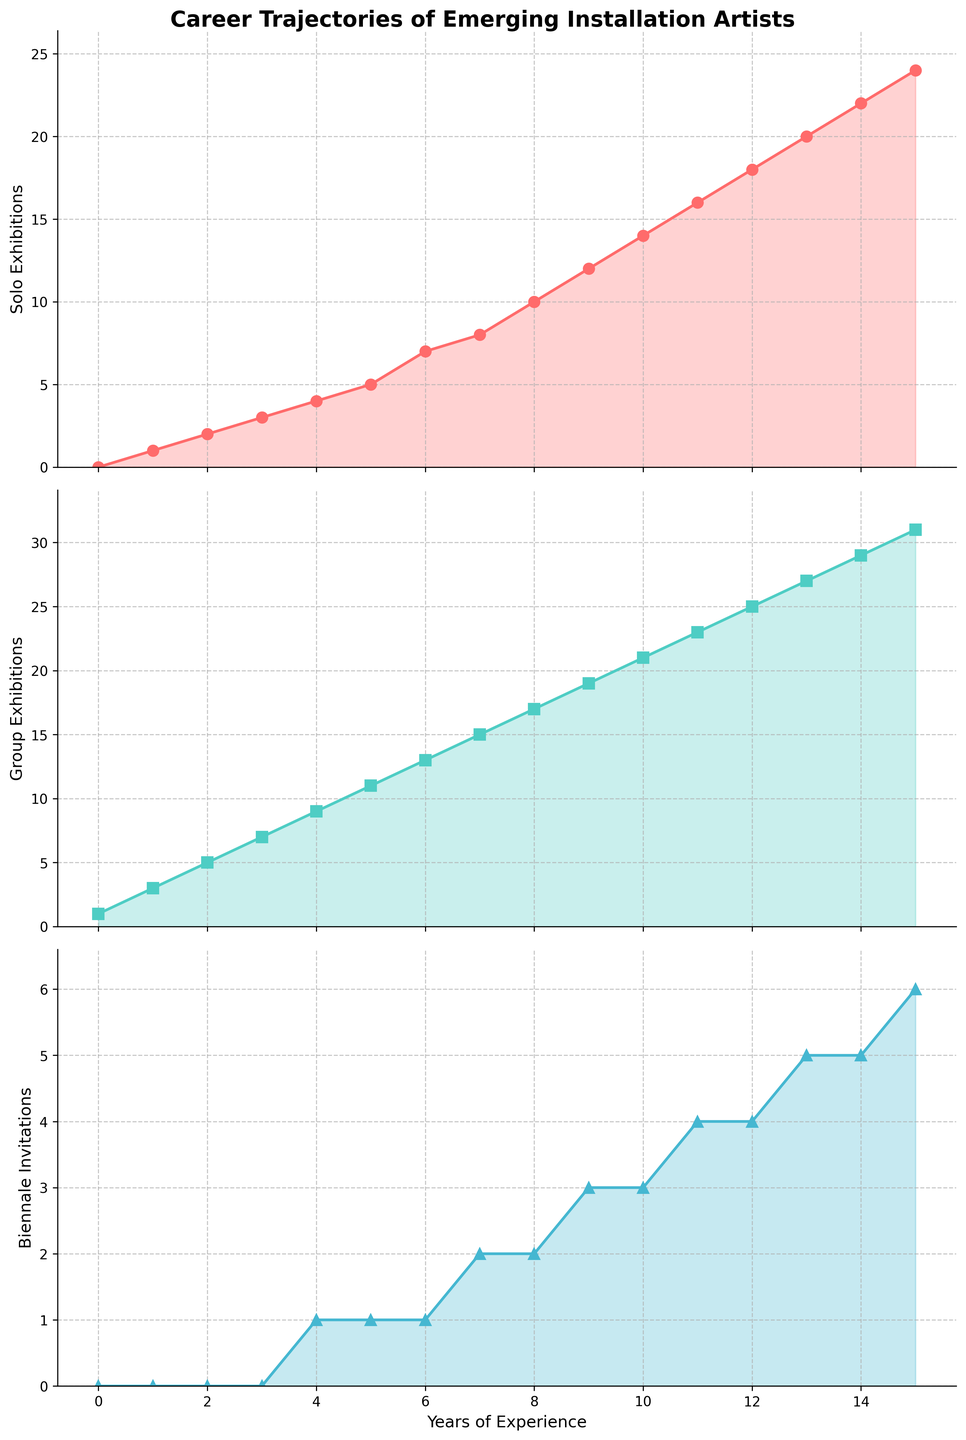What type of exhibitions show the highest growth with years of experience? Look at the three subplots and compare the slopes of the lines. The Group Exhibitions show the highest growth rate with years of experience followed by Solo Exhibitions and Biennale Invitations. The slopes indicate how rapidly each type of exhibition opportunity increases over the years.
Answer: Group Exhibitions By the 5th year of experience, how many Biennale invitations have artists received? Locate the point on the Biennale Invitations subplot where the x-axis value is 5. The corresponding y-axis value is 1, indicating 1 Biennale Invitation.
Answer: 1 On average, how many solo and group exhibitions do artists have in their 10th year? Add the values for Solo Exhibitions and Group Exhibitions for Year 10 and divide by 2. Solo Exhibitions: 14, Group Exhibitions: 21. Average = (14 + 21) / 2 = 17.5.
Answer: 17.5 At what years' experience do Biennale invitations reach 4? Identify the y-value of 4 on the Biennale Invitations subplot and note the corresponding x-axis years. This occurs between the 11th and 12th year of experience.
Answer: 11 or 12 Which exhibition type is shown in green in the plots? Observe the color coding of the lines in all three subplots. The Group Exhibitions line is identified as green.
Answer: Group Exhibitions Between the artists with 3 and 9 years of experience, how many more group exhibitions are there compared to solo exhibitions? Determine the values for both types at 3 and 9 years of experience. Calculate the difference for each year and sum it up. Group: (19 - 7) = 12; Solo: (12 - 3) = 9; Difference: 12 - 9 = 3.
Answer: 3 How does the growth rate of Biennale Invitations compare to Solo Exhibitions after 6 years? Examine both plots after the 6th-year mark. Biennale Invitations grow more slowly than Solo Exhibitions. Solo Exhibitions increase by 17 in the next 9 years, while Biennale Invitations increase by 5.
Answer: Slower By year 8, calculate the ratio of group exhibitions to total exhibitions (solo + group). Look at year 8, Solo Exhibitions: 10, Group Exhibitions: 17. Total = 10 + 17 = 27, so the ratio is 17/27.
Answer: 17/27 In which years do the number of solo exhibitions increase by 2? Identify the years where the Solo Exhibitions subplot shows an increase of exactly 2 from the previous year. This occurs between years 6 and 7, and years 8 and 9.
Answer: Between years 6-7 and 8-9 What is the trend in the number of Biennale Invitations from year 12 to year 15? Analyze the Biennale Invitations subplot. From year 12 to 15, the number increases from 4 to 6, showing a steady upward trend.
Answer: Steady upward trend 